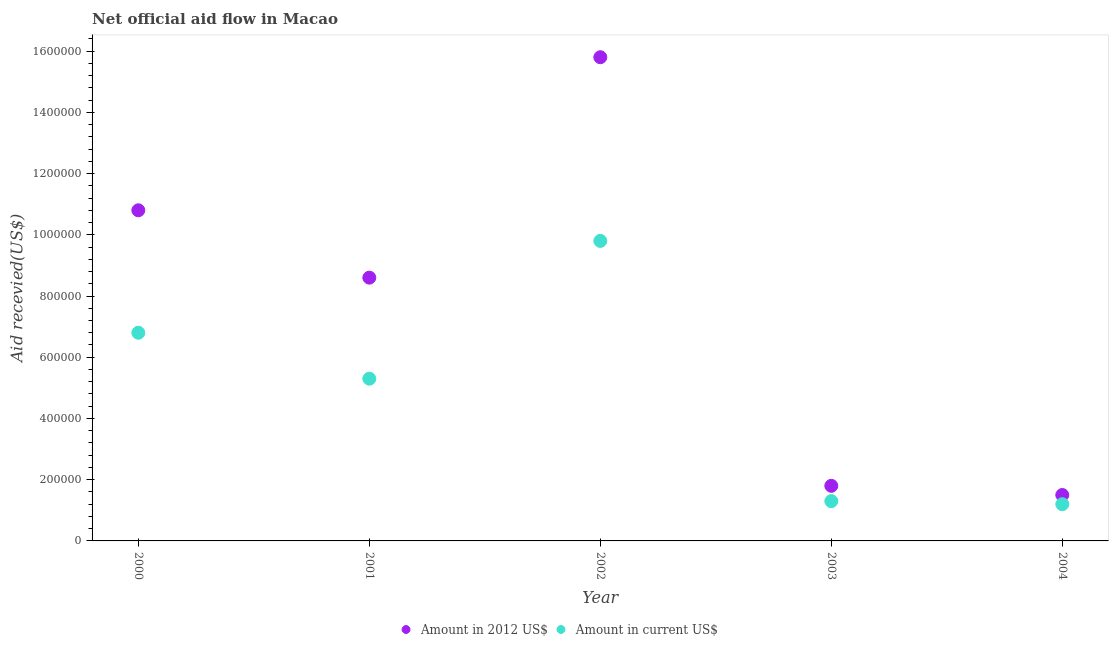How many different coloured dotlines are there?
Offer a very short reply. 2. Is the number of dotlines equal to the number of legend labels?
Your answer should be very brief. Yes. What is the amount of aid received(expressed in us$) in 2002?
Make the answer very short. 9.80e+05. Across all years, what is the maximum amount of aid received(expressed in us$)?
Provide a succinct answer. 9.80e+05. Across all years, what is the minimum amount of aid received(expressed in us$)?
Your answer should be very brief. 1.20e+05. What is the total amount of aid received(expressed in us$) in the graph?
Your answer should be very brief. 2.44e+06. What is the difference between the amount of aid received(expressed in us$) in 2001 and that in 2004?
Offer a terse response. 4.10e+05. What is the difference between the amount of aid received(expressed in 2012 us$) in 2001 and the amount of aid received(expressed in us$) in 2002?
Your response must be concise. -1.20e+05. What is the average amount of aid received(expressed in us$) per year?
Your answer should be compact. 4.88e+05. In the year 2003, what is the difference between the amount of aid received(expressed in 2012 us$) and amount of aid received(expressed in us$)?
Your answer should be compact. 5.00e+04. What is the ratio of the amount of aid received(expressed in 2012 us$) in 2002 to that in 2003?
Provide a succinct answer. 8.78. Is the amount of aid received(expressed in us$) in 2002 less than that in 2003?
Ensure brevity in your answer.  No. What is the difference between the highest and the lowest amount of aid received(expressed in us$)?
Provide a short and direct response. 8.60e+05. Is the sum of the amount of aid received(expressed in us$) in 2000 and 2001 greater than the maximum amount of aid received(expressed in 2012 us$) across all years?
Offer a very short reply. No. Does the amount of aid received(expressed in 2012 us$) monotonically increase over the years?
Offer a terse response. No. How many dotlines are there?
Provide a succinct answer. 2. Does the graph contain any zero values?
Keep it short and to the point. No. Where does the legend appear in the graph?
Your answer should be very brief. Bottom center. How many legend labels are there?
Your answer should be very brief. 2. How are the legend labels stacked?
Offer a terse response. Horizontal. What is the title of the graph?
Make the answer very short. Net official aid flow in Macao. What is the label or title of the Y-axis?
Make the answer very short. Aid recevied(US$). What is the Aid recevied(US$) of Amount in 2012 US$ in 2000?
Provide a succinct answer. 1.08e+06. What is the Aid recevied(US$) of Amount in current US$ in 2000?
Offer a terse response. 6.80e+05. What is the Aid recevied(US$) of Amount in 2012 US$ in 2001?
Keep it short and to the point. 8.60e+05. What is the Aid recevied(US$) in Amount in current US$ in 2001?
Your response must be concise. 5.30e+05. What is the Aid recevied(US$) of Amount in 2012 US$ in 2002?
Your response must be concise. 1.58e+06. What is the Aid recevied(US$) of Amount in current US$ in 2002?
Provide a succinct answer. 9.80e+05. What is the Aid recevied(US$) in Amount in current US$ in 2003?
Make the answer very short. 1.30e+05. What is the Aid recevied(US$) of Amount in current US$ in 2004?
Keep it short and to the point. 1.20e+05. Across all years, what is the maximum Aid recevied(US$) in Amount in 2012 US$?
Ensure brevity in your answer.  1.58e+06. Across all years, what is the maximum Aid recevied(US$) of Amount in current US$?
Ensure brevity in your answer.  9.80e+05. What is the total Aid recevied(US$) in Amount in 2012 US$ in the graph?
Your answer should be very brief. 3.85e+06. What is the total Aid recevied(US$) in Amount in current US$ in the graph?
Provide a short and direct response. 2.44e+06. What is the difference between the Aid recevied(US$) in Amount in 2012 US$ in 2000 and that in 2002?
Your response must be concise. -5.00e+05. What is the difference between the Aid recevied(US$) of Amount in current US$ in 2000 and that in 2002?
Your response must be concise. -3.00e+05. What is the difference between the Aid recevied(US$) of Amount in 2012 US$ in 2000 and that in 2003?
Offer a very short reply. 9.00e+05. What is the difference between the Aid recevied(US$) in Amount in 2012 US$ in 2000 and that in 2004?
Offer a terse response. 9.30e+05. What is the difference between the Aid recevied(US$) in Amount in current US$ in 2000 and that in 2004?
Your response must be concise. 5.60e+05. What is the difference between the Aid recevied(US$) of Amount in 2012 US$ in 2001 and that in 2002?
Provide a succinct answer. -7.20e+05. What is the difference between the Aid recevied(US$) of Amount in current US$ in 2001 and that in 2002?
Provide a succinct answer. -4.50e+05. What is the difference between the Aid recevied(US$) in Amount in 2012 US$ in 2001 and that in 2003?
Provide a succinct answer. 6.80e+05. What is the difference between the Aid recevied(US$) of Amount in current US$ in 2001 and that in 2003?
Make the answer very short. 4.00e+05. What is the difference between the Aid recevied(US$) of Amount in 2012 US$ in 2001 and that in 2004?
Ensure brevity in your answer.  7.10e+05. What is the difference between the Aid recevied(US$) in Amount in 2012 US$ in 2002 and that in 2003?
Your answer should be very brief. 1.40e+06. What is the difference between the Aid recevied(US$) of Amount in current US$ in 2002 and that in 2003?
Keep it short and to the point. 8.50e+05. What is the difference between the Aid recevied(US$) in Amount in 2012 US$ in 2002 and that in 2004?
Provide a succinct answer. 1.43e+06. What is the difference between the Aid recevied(US$) of Amount in current US$ in 2002 and that in 2004?
Your response must be concise. 8.60e+05. What is the difference between the Aid recevied(US$) in Amount in current US$ in 2003 and that in 2004?
Provide a short and direct response. 10000. What is the difference between the Aid recevied(US$) in Amount in 2012 US$ in 2000 and the Aid recevied(US$) in Amount in current US$ in 2001?
Your response must be concise. 5.50e+05. What is the difference between the Aid recevied(US$) in Amount in 2012 US$ in 2000 and the Aid recevied(US$) in Amount in current US$ in 2002?
Offer a terse response. 1.00e+05. What is the difference between the Aid recevied(US$) in Amount in 2012 US$ in 2000 and the Aid recevied(US$) in Amount in current US$ in 2003?
Make the answer very short. 9.50e+05. What is the difference between the Aid recevied(US$) of Amount in 2012 US$ in 2000 and the Aid recevied(US$) of Amount in current US$ in 2004?
Offer a terse response. 9.60e+05. What is the difference between the Aid recevied(US$) in Amount in 2012 US$ in 2001 and the Aid recevied(US$) in Amount in current US$ in 2002?
Ensure brevity in your answer.  -1.20e+05. What is the difference between the Aid recevied(US$) in Amount in 2012 US$ in 2001 and the Aid recevied(US$) in Amount in current US$ in 2003?
Make the answer very short. 7.30e+05. What is the difference between the Aid recevied(US$) in Amount in 2012 US$ in 2001 and the Aid recevied(US$) in Amount in current US$ in 2004?
Offer a terse response. 7.40e+05. What is the difference between the Aid recevied(US$) of Amount in 2012 US$ in 2002 and the Aid recevied(US$) of Amount in current US$ in 2003?
Offer a terse response. 1.45e+06. What is the difference between the Aid recevied(US$) of Amount in 2012 US$ in 2002 and the Aid recevied(US$) of Amount in current US$ in 2004?
Make the answer very short. 1.46e+06. What is the average Aid recevied(US$) in Amount in 2012 US$ per year?
Your answer should be compact. 7.70e+05. What is the average Aid recevied(US$) in Amount in current US$ per year?
Ensure brevity in your answer.  4.88e+05. In the year 2000, what is the difference between the Aid recevied(US$) in Amount in 2012 US$ and Aid recevied(US$) in Amount in current US$?
Offer a very short reply. 4.00e+05. In the year 2001, what is the difference between the Aid recevied(US$) in Amount in 2012 US$ and Aid recevied(US$) in Amount in current US$?
Ensure brevity in your answer.  3.30e+05. In the year 2002, what is the difference between the Aid recevied(US$) of Amount in 2012 US$ and Aid recevied(US$) of Amount in current US$?
Your answer should be compact. 6.00e+05. What is the ratio of the Aid recevied(US$) of Amount in 2012 US$ in 2000 to that in 2001?
Provide a short and direct response. 1.26. What is the ratio of the Aid recevied(US$) in Amount in current US$ in 2000 to that in 2001?
Offer a terse response. 1.28. What is the ratio of the Aid recevied(US$) in Amount in 2012 US$ in 2000 to that in 2002?
Offer a terse response. 0.68. What is the ratio of the Aid recevied(US$) of Amount in current US$ in 2000 to that in 2002?
Offer a terse response. 0.69. What is the ratio of the Aid recevied(US$) in Amount in current US$ in 2000 to that in 2003?
Offer a terse response. 5.23. What is the ratio of the Aid recevied(US$) in Amount in current US$ in 2000 to that in 2004?
Offer a very short reply. 5.67. What is the ratio of the Aid recevied(US$) of Amount in 2012 US$ in 2001 to that in 2002?
Provide a short and direct response. 0.54. What is the ratio of the Aid recevied(US$) in Amount in current US$ in 2001 to that in 2002?
Offer a very short reply. 0.54. What is the ratio of the Aid recevied(US$) of Amount in 2012 US$ in 2001 to that in 2003?
Give a very brief answer. 4.78. What is the ratio of the Aid recevied(US$) in Amount in current US$ in 2001 to that in 2003?
Provide a short and direct response. 4.08. What is the ratio of the Aid recevied(US$) of Amount in 2012 US$ in 2001 to that in 2004?
Your response must be concise. 5.73. What is the ratio of the Aid recevied(US$) in Amount in current US$ in 2001 to that in 2004?
Make the answer very short. 4.42. What is the ratio of the Aid recevied(US$) of Amount in 2012 US$ in 2002 to that in 2003?
Offer a terse response. 8.78. What is the ratio of the Aid recevied(US$) of Amount in current US$ in 2002 to that in 2003?
Give a very brief answer. 7.54. What is the ratio of the Aid recevied(US$) of Amount in 2012 US$ in 2002 to that in 2004?
Provide a short and direct response. 10.53. What is the ratio of the Aid recevied(US$) of Amount in current US$ in 2002 to that in 2004?
Offer a terse response. 8.17. What is the ratio of the Aid recevied(US$) in Amount in 2012 US$ in 2003 to that in 2004?
Your answer should be compact. 1.2. What is the ratio of the Aid recevied(US$) of Amount in current US$ in 2003 to that in 2004?
Provide a succinct answer. 1.08. What is the difference between the highest and the second highest Aid recevied(US$) of Amount in current US$?
Offer a terse response. 3.00e+05. What is the difference between the highest and the lowest Aid recevied(US$) of Amount in 2012 US$?
Your answer should be compact. 1.43e+06. What is the difference between the highest and the lowest Aid recevied(US$) in Amount in current US$?
Make the answer very short. 8.60e+05. 